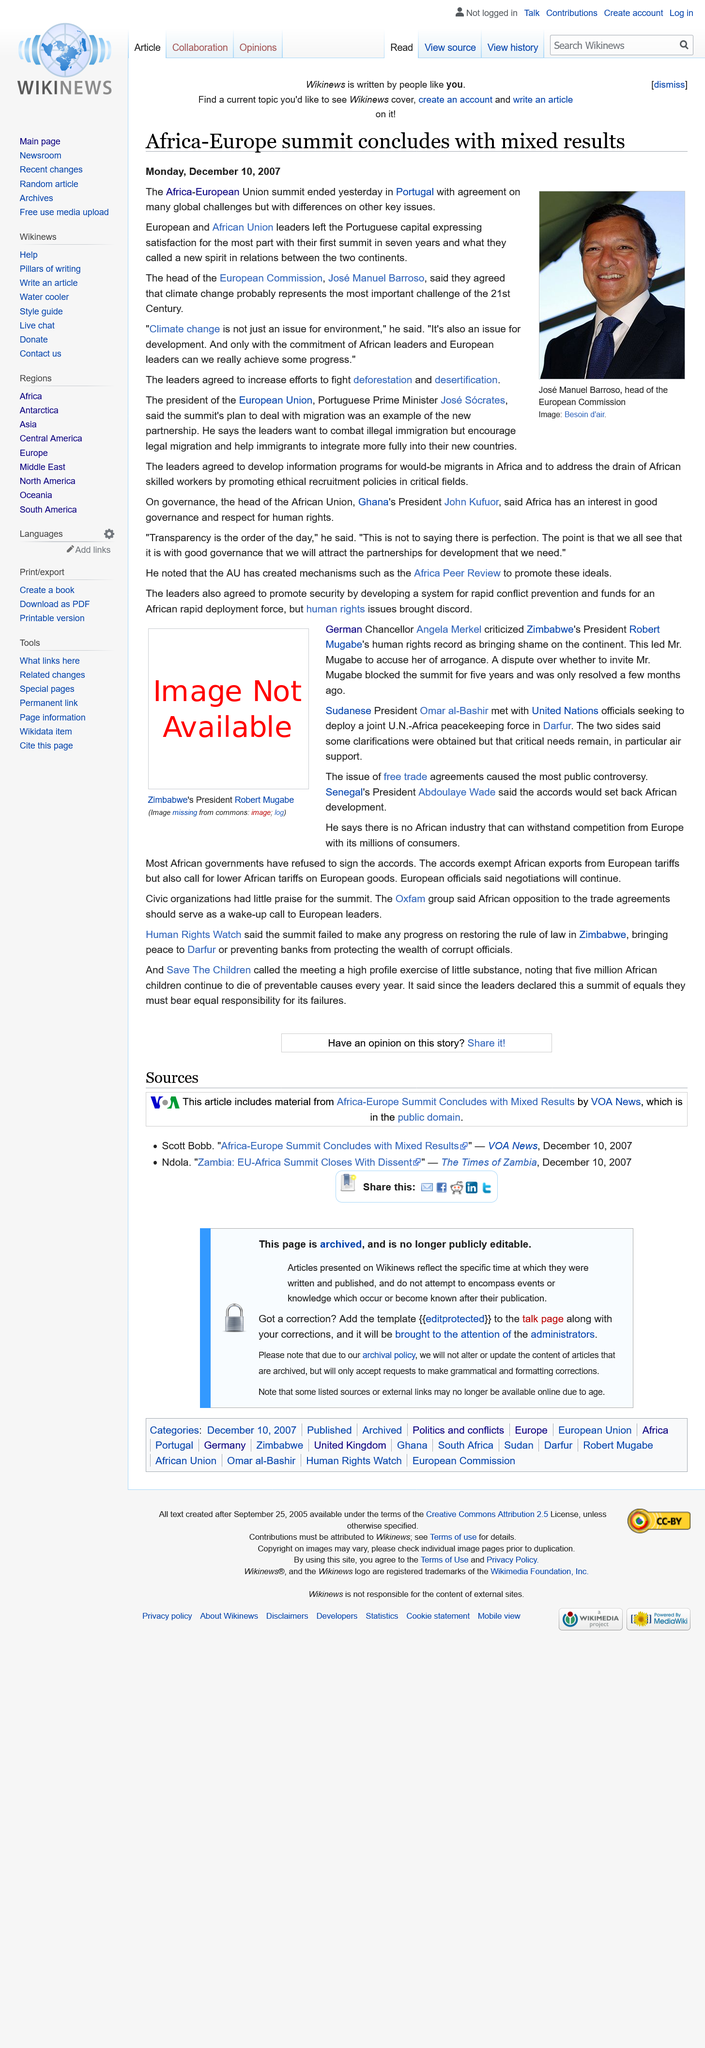Specify some key components in this picture. At the Africa-European Union summit, leaders took important steps to combat deforestation and desertification by increasing their efforts in these areas. The head of the European Commission is Jose Manuel Barroso. Jose Socrates is the current president of the European Union. 